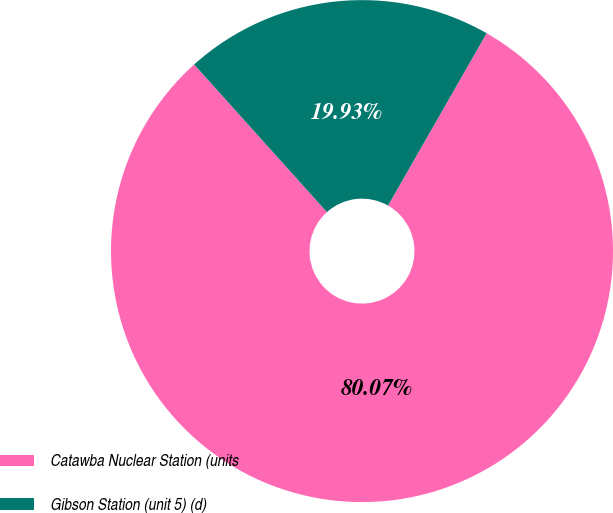Convert chart to OTSL. <chart><loc_0><loc_0><loc_500><loc_500><pie_chart><fcel>Catawba Nuclear Station (units<fcel>Gibson Station (unit 5) (d)<nl><fcel>80.07%<fcel>19.93%<nl></chart> 